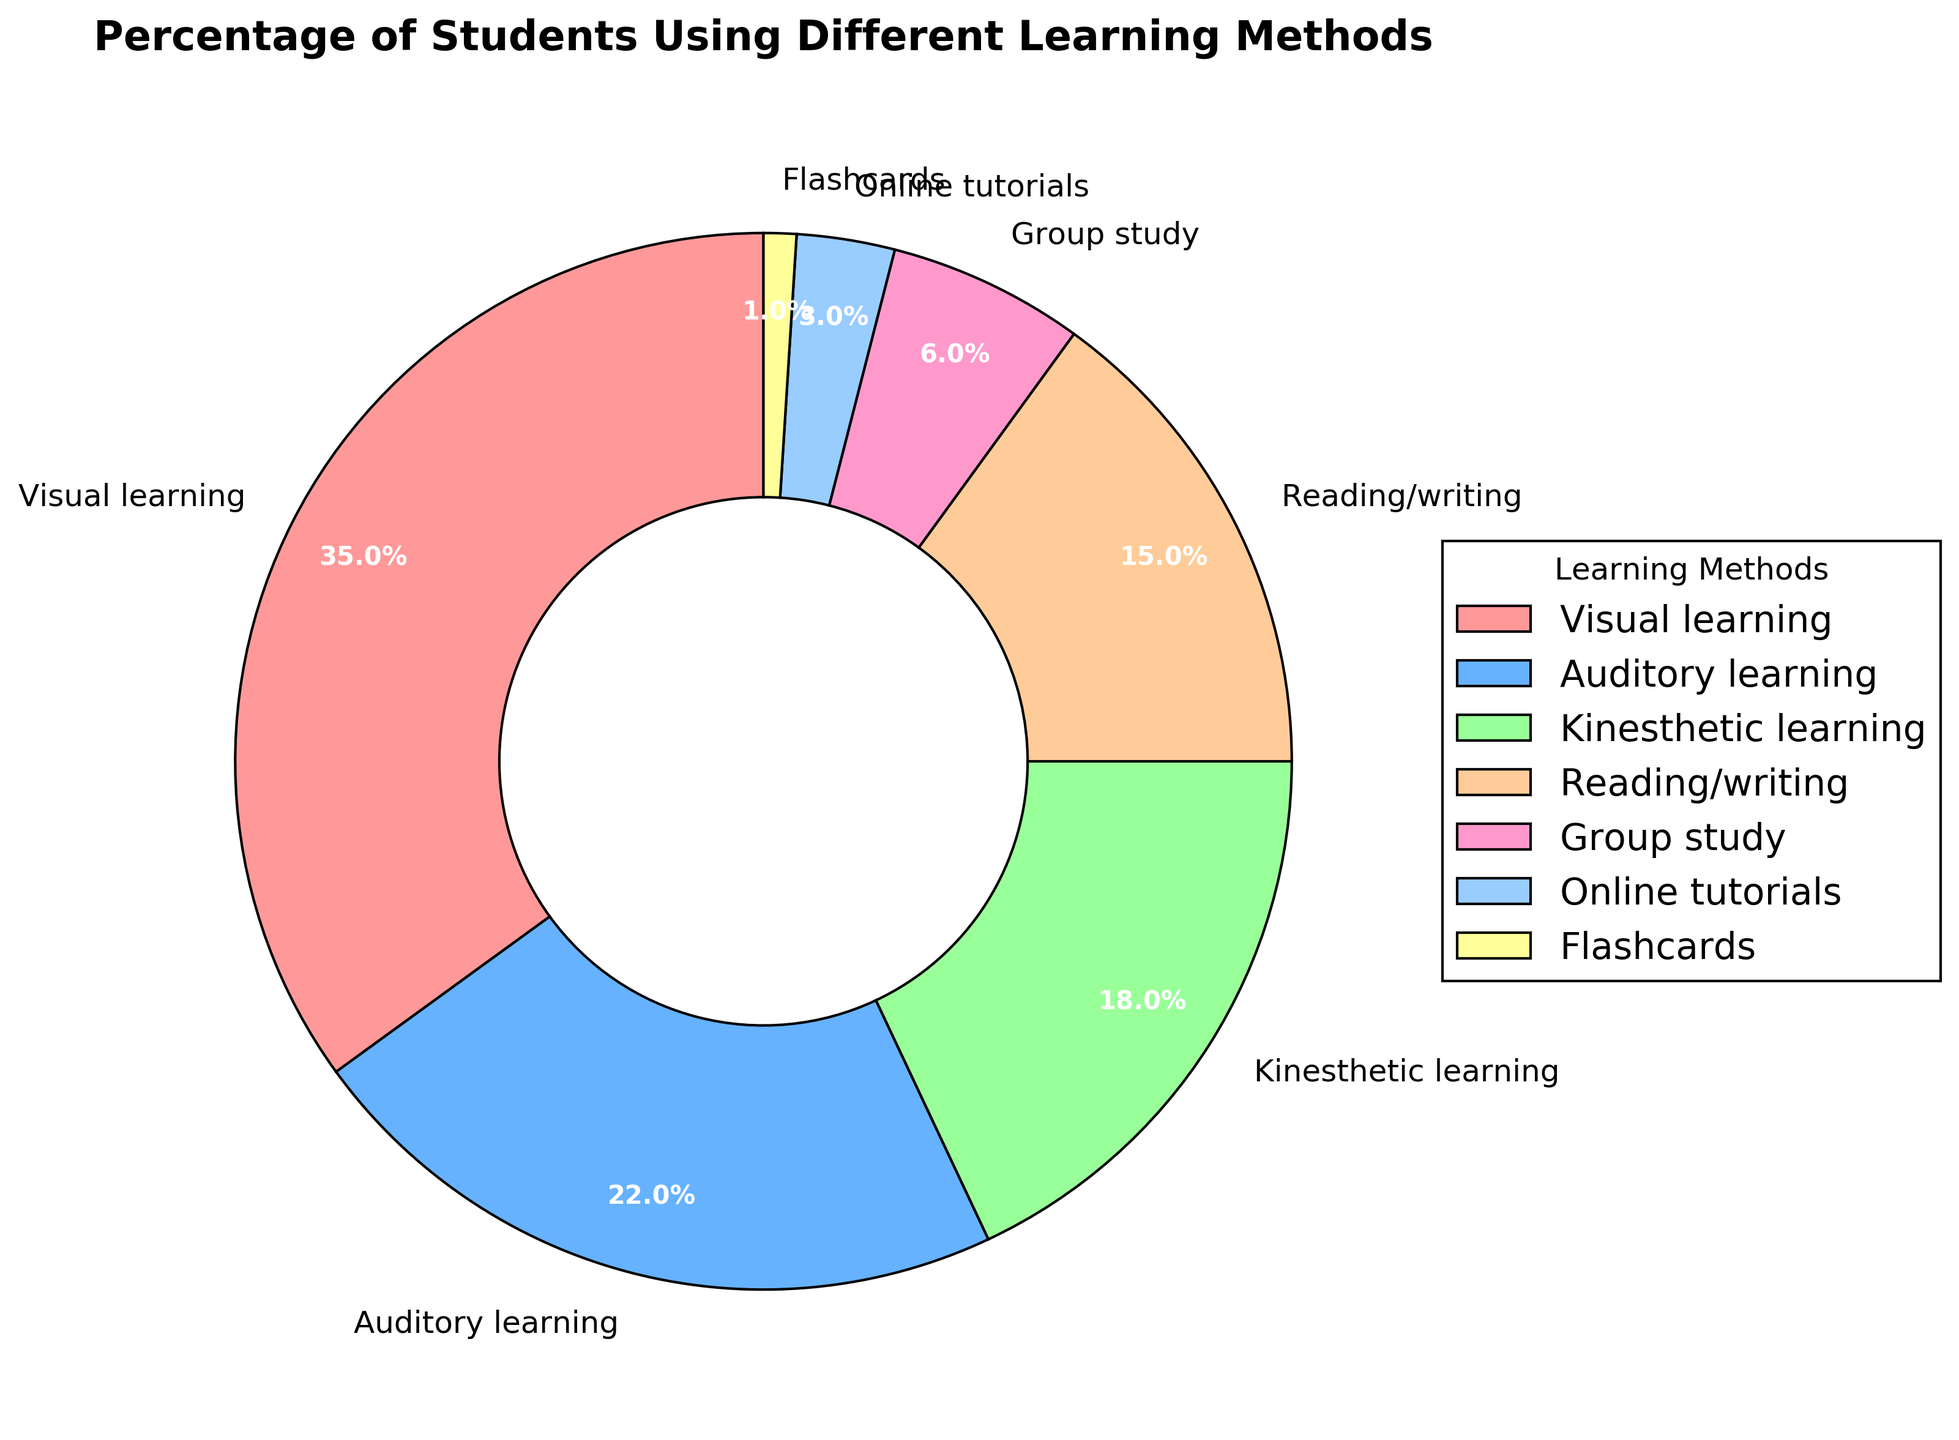What learning method has the highest percentage of students using it? The largest wedge in the pie chart represents Visual learning, which occupies 35% of the pie chart, making it the highest percentage.
Answer: Visual learning What are the combined percentages of Auditory learning and Reading/writing? From the pie chart, Auditory learning is 22% and Reading/writing is 15%, so their combined percentage is 22 + 15 = 37%
Answer: 37% Which learning methods have a higher percentage than Kinesthetic learning? The pie chart shows Visual learning has 35% and Auditory learning has 22%, both of which are higher than Kinesthetic learning at 18%
Answer: Visual learning, Auditory learning What percentage of students use methods other than Visual, Auditory, and Kinesthetic learning? First, sum the percentages of Visual, Auditory, and Kinesthetic learning: 35% + 22% + 18% = 75%. Then, subtract this from 100%: 100% - 75% = 25%.
Answer: 25% List the learning methods that have less than 10% of students using them. The pie chart shows Group study (6%), Online tutorials (3%), and Flashcards (1%), each with less than 10%.
Answer: Group study, Online tutorials, Flashcards Compare the percentages of Group study and Online tutorials. Which one is higher? Group study is 6% and Online tutorials is 3% from the pie chart. Since 6% is greater than 3%, Group study is higher.
Answer: Group study What is the difference in percentage between Visual learning and Flashcards? Visual learning is 35% and Flashcards is 1%. The difference is 35 - 1 = 34%.
Answer: 34% Which color represents Kinesthetic learning? By matching the segments' colors to the label, the color representing Kinesthetic learning can be identified as green.
Answer: green Is the combined percentage of Group study, Online tutorials, and Flashcards more or less than that of Reading/writing? The combined percentage of Group study (6%), Online tutorials (3%), and Flashcards (1%) is 6 + 3 + 1 = 10%. Reading/writing is 15%. Since 10% is less than 15%, the combined percentage is less.
Answer: less 